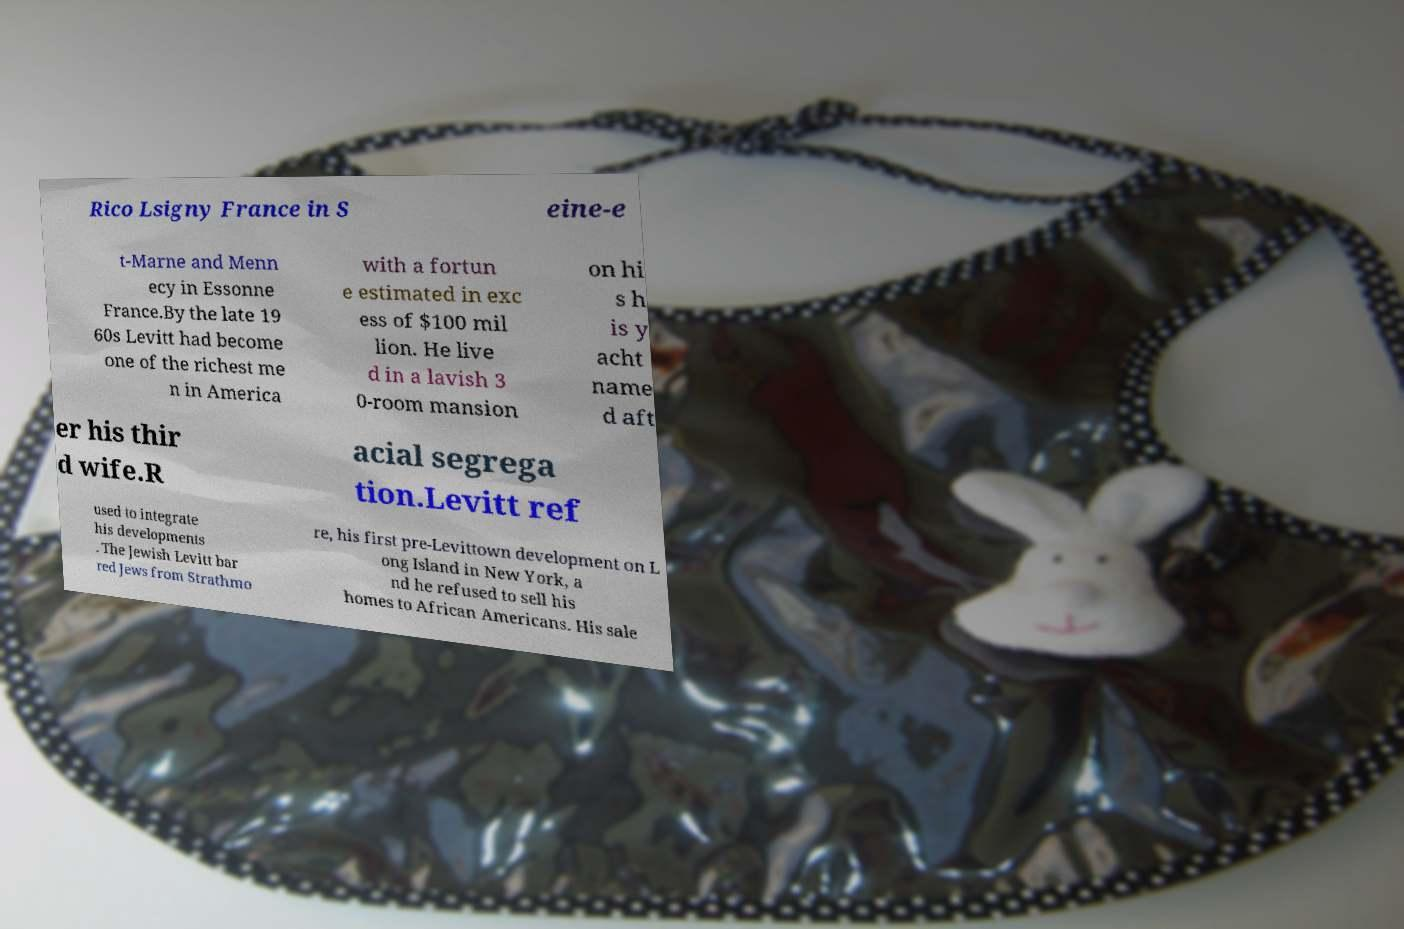There's text embedded in this image that I need extracted. Can you transcribe it verbatim? Rico Lsigny France in S eine-e t-Marne and Menn ecy in Essonne France.By the late 19 60s Levitt had become one of the richest me n in America with a fortun e estimated in exc ess of $100 mil lion. He live d in a lavish 3 0-room mansion on hi s h is y acht name d aft er his thir d wife.R acial segrega tion.Levitt ref used to integrate his developments . The Jewish Levitt bar red Jews from Strathmo re, his first pre-Levittown development on L ong Island in New York, a nd he refused to sell his homes to African Americans. His sale 